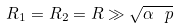Convert formula to latex. <formula><loc_0><loc_0><loc_500><loc_500>R _ { 1 } = R _ { 2 } = R \gg \sqrt { \alpha \ p }</formula> 